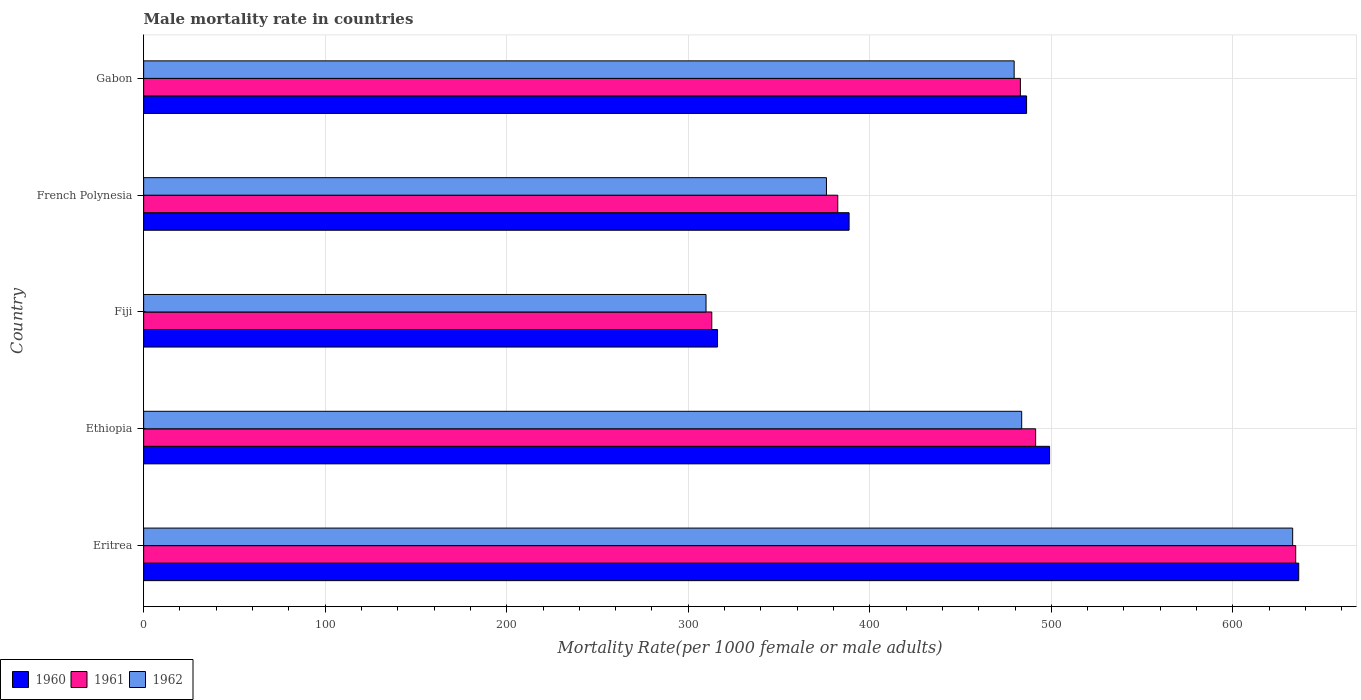How many groups of bars are there?
Ensure brevity in your answer.  5. How many bars are there on the 3rd tick from the bottom?
Provide a succinct answer. 3. What is the label of the 3rd group of bars from the top?
Make the answer very short. Fiji. What is the male mortality rate in 1961 in French Polynesia?
Your answer should be very brief. 382.37. Across all countries, what is the maximum male mortality rate in 1961?
Provide a succinct answer. 634.63. Across all countries, what is the minimum male mortality rate in 1961?
Provide a succinct answer. 312.96. In which country was the male mortality rate in 1962 maximum?
Offer a very short reply. Eritrea. In which country was the male mortality rate in 1961 minimum?
Provide a short and direct response. Fiji. What is the total male mortality rate in 1960 in the graph?
Make the answer very short. 2326.47. What is the difference between the male mortality rate in 1962 in Fiji and that in French Polynesia?
Offer a very short reply. -66.33. What is the difference between the male mortality rate in 1962 in Eritrea and the male mortality rate in 1960 in Gabon?
Keep it short and to the point. 146.57. What is the average male mortality rate in 1962 per country?
Offer a very short reply. 456.42. What is the difference between the male mortality rate in 1962 and male mortality rate in 1961 in Fiji?
Your answer should be very brief. -3.17. In how many countries, is the male mortality rate in 1960 greater than 120 ?
Give a very brief answer. 5. What is the ratio of the male mortality rate in 1961 in Eritrea to that in French Polynesia?
Offer a very short reply. 1.66. What is the difference between the highest and the second highest male mortality rate in 1961?
Ensure brevity in your answer.  143.26. What is the difference between the highest and the lowest male mortality rate in 1961?
Your answer should be very brief. 321.66. In how many countries, is the male mortality rate in 1960 greater than the average male mortality rate in 1960 taken over all countries?
Give a very brief answer. 3. What does the 2nd bar from the bottom in Gabon represents?
Provide a short and direct response. 1961. Is it the case that in every country, the sum of the male mortality rate in 1961 and male mortality rate in 1960 is greater than the male mortality rate in 1962?
Your response must be concise. Yes. Are all the bars in the graph horizontal?
Give a very brief answer. Yes. What is the difference between two consecutive major ticks on the X-axis?
Keep it short and to the point. 100. Are the values on the major ticks of X-axis written in scientific E-notation?
Your answer should be very brief. No. Does the graph contain any zero values?
Your answer should be very brief. No. Does the graph contain grids?
Provide a short and direct response. Yes. How are the legend labels stacked?
Ensure brevity in your answer.  Horizontal. What is the title of the graph?
Offer a terse response. Male mortality rate in countries. Does "2009" appear as one of the legend labels in the graph?
Offer a terse response. No. What is the label or title of the X-axis?
Ensure brevity in your answer.  Mortality Rate(per 1000 female or male adults). What is the label or title of the Y-axis?
Offer a very short reply. Country. What is the Mortality Rate(per 1000 female or male adults) in 1960 in Eritrea?
Your response must be concise. 636.3. What is the Mortality Rate(per 1000 female or male adults) of 1961 in Eritrea?
Ensure brevity in your answer.  634.63. What is the Mortality Rate(per 1000 female or male adults) in 1962 in Eritrea?
Provide a short and direct response. 632.96. What is the Mortality Rate(per 1000 female or male adults) in 1960 in Ethiopia?
Give a very brief answer. 499.05. What is the Mortality Rate(per 1000 female or male adults) in 1961 in Ethiopia?
Your answer should be compact. 491.37. What is the Mortality Rate(per 1000 female or male adults) in 1962 in Ethiopia?
Offer a very short reply. 483.68. What is the Mortality Rate(per 1000 female or male adults) in 1960 in Fiji?
Provide a succinct answer. 316.13. What is the Mortality Rate(per 1000 female or male adults) in 1961 in Fiji?
Your response must be concise. 312.96. What is the Mortality Rate(per 1000 female or male adults) in 1962 in Fiji?
Offer a very short reply. 309.8. What is the Mortality Rate(per 1000 female or male adults) of 1960 in French Polynesia?
Your response must be concise. 388.6. What is the Mortality Rate(per 1000 female or male adults) of 1961 in French Polynesia?
Provide a succinct answer. 382.37. What is the Mortality Rate(per 1000 female or male adults) in 1962 in French Polynesia?
Make the answer very short. 376.13. What is the Mortality Rate(per 1000 female or male adults) of 1960 in Gabon?
Offer a very short reply. 486.38. What is the Mortality Rate(per 1000 female or male adults) of 1961 in Gabon?
Ensure brevity in your answer.  482.95. What is the Mortality Rate(per 1000 female or male adults) of 1962 in Gabon?
Keep it short and to the point. 479.53. Across all countries, what is the maximum Mortality Rate(per 1000 female or male adults) of 1960?
Make the answer very short. 636.3. Across all countries, what is the maximum Mortality Rate(per 1000 female or male adults) in 1961?
Offer a terse response. 634.63. Across all countries, what is the maximum Mortality Rate(per 1000 female or male adults) of 1962?
Make the answer very short. 632.96. Across all countries, what is the minimum Mortality Rate(per 1000 female or male adults) in 1960?
Provide a succinct answer. 316.13. Across all countries, what is the minimum Mortality Rate(per 1000 female or male adults) of 1961?
Provide a short and direct response. 312.96. Across all countries, what is the minimum Mortality Rate(per 1000 female or male adults) in 1962?
Offer a very short reply. 309.8. What is the total Mortality Rate(per 1000 female or male adults) of 1960 in the graph?
Offer a very short reply. 2326.47. What is the total Mortality Rate(per 1000 female or male adults) of 1961 in the graph?
Your answer should be compact. 2304.28. What is the total Mortality Rate(per 1000 female or male adults) in 1962 in the graph?
Provide a short and direct response. 2282.1. What is the difference between the Mortality Rate(per 1000 female or male adults) of 1960 in Eritrea and that in Ethiopia?
Keep it short and to the point. 137.24. What is the difference between the Mortality Rate(per 1000 female or male adults) of 1961 in Eritrea and that in Ethiopia?
Offer a very short reply. 143.26. What is the difference between the Mortality Rate(per 1000 female or male adults) of 1962 in Eritrea and that in Ethiopia?
Your answer should be compact. 149.28. What is the difference between the Mortality Rate(per 1000 female or male adults) in 1960 in Eritrea and that in Fiji?
Your response must be concise. 320.17. What is the difference between the Mortality Rate(per 1000 female or male adults) in 1961 in Eritrea and that in Fiji?
Provide a succinct answer. 321.66. What is the difference between the Mortality Rate(per 1000 female or male adults) of 1962 in Eritrea and that in Fiji?
Your response must be concise. 323.16. What is the difference between the Mortality Rate(per 1000 female or male adults) in 1960 in Eritrea and that in French Polynesia?
Give a very brief answer. 247.69. What is the difference between the Mortality Rate(per 1000 female or male adults) in 1961 in Eritrea and that in French Polynesia?
Your answer should be very brief. 252.26. What is the difference between the Mortality Rate(per 1000 female or male adults) of 1962 in Eritrea and that in French Polynesia?
Ensure brevity in your answer.  256.82. What is the difference between the Mortality Rate(per 1000 female or male adults) in 1960 in Eritrea and that in Gabon?
Your answer should be very brief. 149.91. What is the difference between the Mortality Rate(per 1000 female or male adults) of 1961 in Eritrea and that in Gabon?
Keep it short and to the point. 151.67. What is the difference between the Mortality Rate(per 1000 female or male adults) of 1962 in Eritrea and that in Gabon?
Your answer should be compact. 153.43. What is the difference between the Mortality Rate(per 1000 female or male adults) of 1960 in Ethiopia and that in Fiji?
Your response must be concise. 182.93. What is the difference between the Mortality Rate(per 1000 female or male adults) in 1961 in Ethiopia and that in Fiji?
Your response must be concise. 178.41. What is the difference between the Mortality Rate(per 1000 female or male adults) of 1962 in Ethiopia and that in Fiji?
Provide a short and direct response. 173.88. What is the difference between the Mortality Rate(per 1000 female or male adults) in 1960 in Ethiopia and that in French Polynesia?
Ensure brevity in your answer.  110.45. What is the difference between the Mortality Rate(per 1000 female or male adults) of 1961 in Ethiopia and that in French Polynesia?
Provide a short and direct response. 109. What is the difference between the Mortality Rate(per 1000 female or male adults) in 1962 in Ethiopia and that in French Polynesia?
Your answer should be compact. 107.55. What is the difference between the Mortality Rate(per 1000 female or male adults) in 1960 in Ethiopia and that in Gabon?
Ensure brevity in your answer.  12.67. What is the difference between the Mortality Rate(per 1000 female or male adults) in 1961 in Ethiopia and that in Gabon?
Your answer should be very brief. 8.41. What is the difference between the Mortality Rate(per 1000 female or male adults) of 1962 in Ethiopia and that in Gabon?
Your response must be concise. 4.15. What is the difference between the Mortality Rate(per 1000 female or male adults) in 1960 in Fiji and that in French Polynesia?
Your answer should be very brief. -72.47. What is the difference between the Mortality Rate(per 1000 female or male adults) in 1961 in Fiji and that in French Polynesia?
Offer a very short reply. -69.41. What is the difference between the Mortality Rate(per 1000 female or male adults) in 1962 in Fiji and that in French Polynesia?
Ensure brevity in your answer.  -66.33. What is the difference between the Mortality Rate(per 1000 female or male adults) in 1960 in Fiji and that in Gabon?
Your answer should be compact. -170.25. What is the difference between the Mortality Rate(per 1000 female or male adults) in 1961 in Fiji and that in Gabon?
Keep it short and to the point. -169.99. What is the difference between the Mortality Rate(per 1000 female or male adults) of 1962 in Fiji and that in Gabon?
Offer a terse response. -169.73. What is the difference between the Mortality Rate(per 1000 female or male adults) of 1960 in French Polynesia and that in Gabon?
Provide a short and direct response. -97.78. What is the difference between the Mortality Rate(per 1000 female or male adults) of 1961 in French Polynesia and that in Gabon?
Ensure brevity in your answer.  -100.59. What is the difference between the Mortality Rate(per 1000 female or male adults) in 1962 in French Polynesia and that in Gabon?
Provide a short and direct response. -103.4. What is the difference between the Mortality Rate(per 1000 female or male adults) in 1960 in Eritrea and the Mortality Rate(per 1000 female or male adults) in 1961 in Ethiopia?
Offer a very short reply. 144.93. What is the difference between the Mortality Rate(per 1000 female or male adults) of 1960 in Eritrea and the Mortality Rate(per 1000 female or male adults) of 1962 in Ethiopia?
Offer a terse response. 152.62. What is the difference between the Mortality Rate(per 1000 female or male adults) of 1961 in Eritrea and the Mortality Rate(per 1000 female or male adults) of 1962 in Ethiopia?
Ensure brevity in your answer.  150.94. What is the difference between the Mortality Rate(per 1000 female or male adults) of 1960 in Eritrea and the Mortality Rate(per 1000 female or male adults) of 1961 in Fiji?
Your answer should be very brief. 323.33. What is the difference between the Mortality Rate(per 1000 female or male adults) of 1960 in Eritrea and the Mortality Rate(per 1000 female or male adults) of 1962 in Fiji?
Offer a very short reply. 326.5. What is the difference between the Mortality Rate(per 1000 female or male adults) of 1961 in Eritrea and the Mortality Rate(per 1000 female or male adults) of 1962 in Fiji?
Offer a very short reply. 324.83. What is the difference between the Mortality Rate(per 1000 female or male adults) in 1960 in Eritrea and the Mortality Rate(per 1000 female or male adults) in 1961 in French Polynesia?
Provide a succinct answer. 253.93. What is the difference between the Mortality Rate(per 1000 female or male adults) of 1960 in Eritrea and the Mortality Rate(per 1000 female or male adults) of 1962 in French Polynesia?
Keep it short and to the point. 260.17. What is the difference between the Mortality Rate(per 1000 female or male adults) of 1961 in Eritrea and the Mortality Rate(per 1000 female or male adults) of 1962 in French Polynesia?
Offer a very short reply. 258.5. What is the difference between the Mortality Rate(per 1000 female or male adults) in 1960 in Eritrea and the Mortality Rate(per 1000 female or male adults) in 1961 in Gabon?
Your answer should be very brief. 153.34. What is the difference between the Mortality Rate(per 1000 female or male adults) of 1960 in Eritrea and the Mortality Rate(per 1000 female or male adults) of 1962 in Gabon?
Provide a succinct answer. 156.77. What is the difference between the Mortality Rate(per 1000 female or male adults) of 1961 in Eritrea and the Mortality Rate(per 1000 female or male adults) of 1962 in Gabon?
Your answer should be very brief. 155.1. What is the difference between the Mortality Rate(per 1000 female or male adults) of 1960 in Ethiopia and the Mortality Rate(per 1000 female or male adults) of 1961 in Fiji?
Your answer should be very brief. 186.09. What is the difference between the Mortality Rate(per 1000 female or male adults) of 1960 in Ethiopia and the Mortality Rate(per 1000 female or male adults) of 1962 in Fiji?
Your answer should be very brief. 189.26. What is the difference between the Mortality Rate(per 1000 female or male adults) in 1961 in Ethiopia and the Mortality Rate(per 1000 female or male adults) in 1962 in Fiji?
Offer a very short reply. 181.57. What is the difference between the Mortality Rate(per 1000 female or male adults) of 1960 in Ethiopia and the Mortality Rate(per 1000 female or male adults) of 1961 in French Polynesia?
Provide a succinct answer. 116.69. What is the difference between the Mortality Rate(per 1000 female or male adults) in 1960 in Ethiopia and the Mortality Rate(per 1000 female or male adults) in 1962 in French Polynesia?
Your answer should be very brief. 122.92. What is the difference between the Mortality Rate(per 1000 female or male adults) in 1961 in Ethiopia and the Mortality Rate(per 1000 female or male adults) in 1962 in French Polynesia?
Keep it short and to the point. 115.24. What is the difference between the Mortality Rate(per 1000 female or male adults) of 1960 in Ethiopia and the Mortality Rate(per 1000 female or male adults) of 1961 in Gabon?
Your answer should be very brief. 16.1. What is the difference between the Mortality Rate(per 1000 female or male adults) in 1960 in Ethiopia and the Mortality Rate(per 1000 female or male adults) in 1962 in Gabon?
Your response must be concise. 19.53. What is the difference between the Mortality Rate(per 1000 female or male adults) of 1961 in Ethiopia and the Mortality Rate(per 1000 female or male adults) of 1962 in Gabon?
Your answer should be compact. 11.84. What is the difference between the Mortality Rate(per 1000 female or male adults) in 1960 in Fiji and the Mortality Rate(per 1000 female or male adults) in 1961 in French Polynesia?
Your answer should be compact. -66.24. What is the difference between the Mortality Rate(per 1000 female or male adults) in 1960 in Fiji and the Mortality Rate(per 1000 female or male adults) in 1962 in French Polynesia?
Make the answer very short. -60. What is the difference between the Mortality Rate(per 1000 female or male adults) of 1961 in Fiji and the Mortality Rate(per 1000 female or male adults) of 1962 in French Polynesia?
Offer a terse response. -63.17. What is the difference between the Mortality Rate(per 1000 female or male adults) in 1960 in Fiji and the Mortality Rate(per 1000 female or male adults) in 1961 in Gabon?
Make the answer very short. -166.83. What is the difference between the Mortality Rate(per 1000 female or male adults) in 1960 in Fiji and the Mortality Rate(per 1000 female or male adults) in 1962 in Gabon?
Provide a short and direct response. -163.4. What is the difference between the Mortality Rate(per 1000 female or male adults) of 1961 in Fiji and the Mortality Rate(per 1000 female or male adults) of 1962 in Gabon?
Keep it short and to the point. -166.56. What is the difference between the Mortality Rate(per 1000 female or male adults) in 1960 in French Polynesia and the Mortality Rate(per 1000 female or male adults) in 1961 in Gabon?
Make the answer very short. -94.35. What is the difference between the Mortality Rate(per 1000 female or male adults) in 1960 in French Polynesia and the Mortality Rate(per 1000 female or male adults) in 1962 in Gabon?
Your response must be concise. -90.92. What is the difference between the Mortality Rate(per 1000 female or male adults) of 1961 in French Polynesia and the Mortality Rate(per 1000 female or male adults) of 1962 in Gabon?
Give a very brief answer. -97.16. What is the average Mortality Rate(per 1000 female or male adults) in 1960 per country?
Provide a succinct answer. 465.29. What is the average Mortality Rate(per 1000 female or male adults) in 1961 per country?
Your response must be concise. 460.86. What is the average Mortality Rate(per 1000 female or male adults) of 1962 per country?
Give a very brief answer. 456.42. What is the difference between the Mortality Rate(per 1000 female or male adults) in 1960 and Mortality Rate(per 1000 female or male adults) in 1961 in Eritrea?
Keep it short and to the point. 1.67. What is the difference between the Mortality Rate(per 1000 female or male adults) in 1960 and Mortality Rate(per 1000 female or male adults) in 1962 in Eritrea?
Your answer should be very brief. 3.34. What is the difference between the Mortality Rate(per 1000 female or male adults) in 1961 and Mortality Rate(per 1000 female or male adults) in 1962 in Eritrea?
Ensure brevity in your answer.  1.67. What is the difference between the Mortality Rate(per 1000 female or male adults) of 1960 and Mortality Rate(per 1000 female or male adults) of 1961 in Ethiopia?
Provide a succinct answer. 7.69. What is the difference between the Mortality Rate(per 1000 female or male adults) in 1960 and Mortality Rate(per 1000 female or male adults) in 1962 in Ethiopia?
Keep it short and to the point. 15.37. What is the difference between the Mortality Rate(per 1000 female or male adults) in 1961 and Mortality Rate(per 1000 female or male adults) in 1962 in Ethiopia?
Give a very brief answer. 7.69. What is the difference between the Mortality Rate(per 1000 female or male adults) of 1960 and Mortality Rate(per 1000 female or male adults) of 1961 in Fiji?
Provide a succinct answer. 3.17. What is the difference between the Mortality Rate(per 1000 female or male adults) in 1960 and Mortality Rate(per 1000 female or male adults) in 1962 in Fiji?
Keep it short and to the point. 6.33. What is the difference between the Mortality Rate(per 1000 female or male adults) of 1961 and Mortality Rate(per 1000 female or male adults) of 1962 in Fiji?
Keep it short and to the point. 3.17. What is the difference between the Mortality Rate(per 1000 female or male adults) of 1960 and Mortality Rate(per 1000 female or male adults) of 1961 in French Polynesia?
Keep it short and to the point. 6.24. What is the difference between the Mortality Rate(per 1000 female or male adults) in 1960 and Mortality Rate(per 1000 female or male adults) in 1962 in French Polynesia?
Your answer should be compact. 12.47. What is the difference between the Mortality Rate(per 1000 female or male adults) in 1961 and Mortality Rate(per 1000 female or male adults) in 1962 in French Polynesia?
Make the answer very short. 6.24. What is the difference between the Mortality Rate(per 1000 female or male adults) in 1960 and Mortality Rate(per 1000 female or male adults) in 1961 in Gabon?
Your response must be concise. 3.43. What is the difference between the Mortality Rate(per 1000 female or male adults) in 1960 and Mortality Rate(per 1000 female or male adults) in 1962 in Gabon?
Your answer should be compact. 6.85. What is the difference between the Mortality Rate(per 1000 female or male adults) of 1961 and Mortality Rate(per 1000 female or male adults) of 1962 in Gabon?
Your answer should be very brief. 3.43. What is the ratio of the Mortality Rate(per 1000 female or male adults) of 1960 in Eritrea to that in Ethiopia?
Your answer should be very brief. 1.27. What is the ratio of the Mortality Rate(per 1000 female or male adults) of 1961 in Eritrea to that in Ethiopia?
Your answer should be compact. 1.29. What is the ratio of the Mortality Rate(per 1000 female or male adults) in 1962 in Eritrea to that in Ethiopia?
Provide a short and direct response. 1.31. What is the ratio of the Mortality Rate(per 1000 female or male adults) of 1960 in Eritrea to that in Fiji?
Make the answer very short. 2.01. What is the ratio of the Mortality Rate(per 1000 female or male adults) of 1961 in Eritrea to that in Fiji?
Offer a very short reply. 2.03. What is the ratio of the Mortality Rate(per 1000 female or male adults) in 1962 in Eritrea to that in Fiji?
Your response must be concise. 2.04. What is the ratio of the Mortality Rate(per 1000 female or male adults) of 1960 in Eritrea to that in French Polynesia?
Ensure brevity in your answer.  1.64. What is the ratio of the Mortality Rate(per 1000 female or male adults) in 1961 in Eritrea to that in French Polynesia?
Provide a succinct answer. 1.66. What is the ratio of the Mortality Rate(per 1000 female or male adults) of 1962 in Eritrea to that in French Polynesia?
Keep it short and to the point. 1.68. What is the ratio of the Mortality Rate(per 1000 female or male adults) of 1960 in Eritrea to that in Gabon?
Keep it short and to the point. 1.31. What is the ratio of the Mortality Rate(per 1000 female or male adults) of 1961 in Eritrea to that in Gabon?
Provide a succinct answer. 1.31. What is the ratio of the Mortality Rate(per 1000 female or male adults) of 1962 in Eritrea to that in Gabon?
Keep it short and to the point. 1.32. What is the ratio of the Mortality Rate(per 1000 female or male adults) in 1960 in Ethiopia to that in Fiji?
Your answer should be compact. 1.58. What is the ratio of the Mortality Rate(per 1000 female or male adults) of 1961 in Ethiopia to that in Fiji?
Offer a terse response. 1.57. What is the ratio of the Mortality Rate(per 1000 female or male adults) of 1962 in Ethiopia to that in Fiji?
Provide a succinct answer. 1.56. What is the ratio of the Mortality Rate(per 1000 female or male adults) of 1960 in Ethiopia to that in French Polynesia?
Provide a succinct answer. 1.28. What is the ratio of the Mortality Rate(per 1000 female or male adults) in 1961 in Ethiopia to that in French Polynesia?
Keep it short and to the point. 1.29. What is the ratio of the Mortality Rate(per 1000 female or male adults) of 1962 in Ethiopia to that in French Polynesia?
Keep it short and to the point. 1.29. What is the ratio of the Mortality Rate(per 1000 female or male adults) of 1960 in Ethiopia to that in Gabon?
Ensure brevity in your answer.  1.03. What is the ratio of the Mortality Rate(per 1000 female or male adults) of 1961 in Ethiopia to that in Gabon?
Provide a short and direct response. 1.02. What is the ratio of the Mortality Rate(per 1000 female or male adults) of 1962 in Ethiopia to that in Gabon?
Make the answer very short. 1.01. What is the ratio of the Mortality Rate(per 1000 female or male adults) of 1960 in Fiji to that in French Polynesia?
Offer a terse response. 0.81. What is the ratio of the Mortality Rate(per 1000 female or male adults) of 1961 in Fiji to that in French Polynesia?
Your answer should be compact. 0.82. What is the ratio of the Mortality Rate(per 1000 female or male adults) of 1962 in Fiji to that in French Polynesia?
Your answer should be compact. 0.82. What is the ratio of the Mortality Rate(per 1000 female or male adults) in 1960 in Fiji to that in Gabon?
Keep it short and to the point. 0.65. What is the ratio of the Mortality Rate(per 1000 female or male adults) of 1961 in Fiji to that in Gabon?
Give a very brief answer. 0.65. What is the ratio of the Mortality Rate(per 1000 female or male adults) of 1962 in Fiji to that in Gabon?
Your answer should be compact. 0.65. What is the ratio of the Mortality Rate(per 1000 female or male adults) in 1960 in French Polynesia to that in Gabon?
Provide a short and direct response. 0.8. What is the ratio of the Mortality Rate(per 1000 female or male adults) in 1961 in French Polynesia to that in Gabon?
Provide a succinct answer. 0.79. What is the ratio of the Mortality Rate(per 1000 female or male adults) of 1962 in French Polynesia to that in Gabon?
Make the answer very short. 0.78. What is the difference between the highest and the second highest Mortality Rate(per 1000 female or male adults) of 1960?
Keep it short and to the point. 137.24. What is the difference between the highest and the second highest Mortality Rate(per 1000 female or male adults) of 1961?
Keep it short and to the point. 143.26. What is the difference between the highest and the second highest Mortality Rate(per 1000 female or male adults) of 1962?
Ensure brevity in your answer.  149.28. What is the difference between the highest and the lowest Mortality Rate(per 1000 female or male adults) in 1960?
Ensure brevity in your answer.  320.17. What is the difference between the highest and the lowest Mortality Rate(per 1000 female or male adults) in 1961?
Provide a short and direct response. 321.66. What is the difference between the highest and the lowest Mortality Rate(per 1000 female or male adults) in 1962?
Provide a succinct answer. 323.16. 